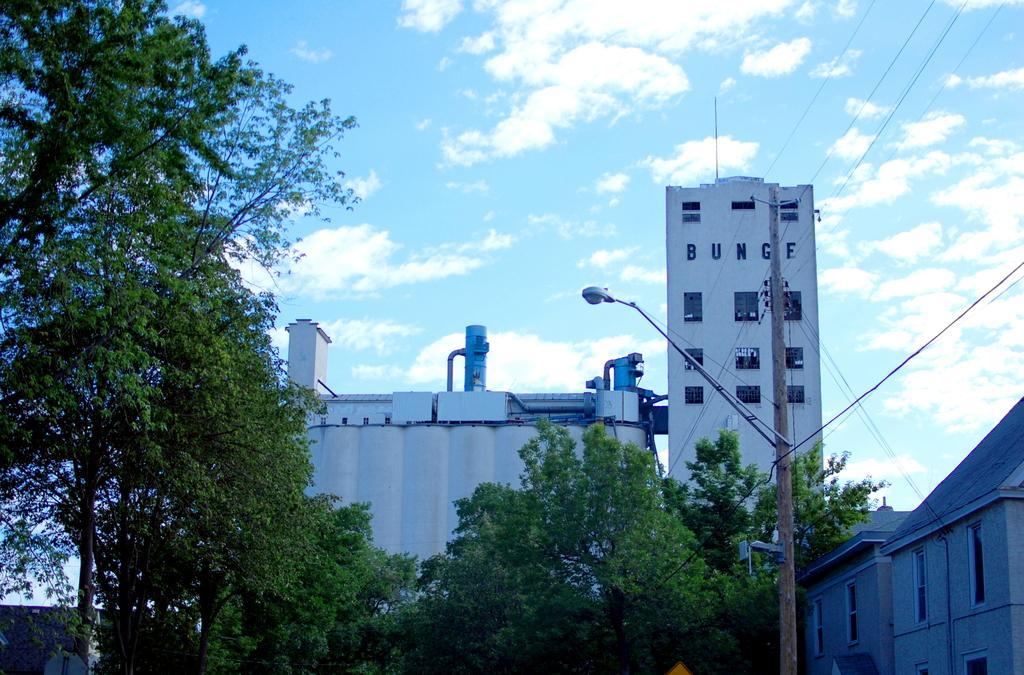Please provide a concise description of this image. In this picture we can see buildings, trees and street lights. 